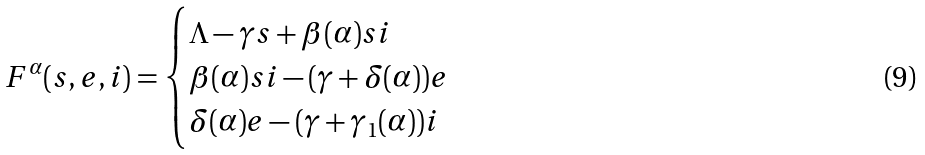Convert formula to latex. <formula><loc_0><loc_0><loc_500><loc_500>F ^ { \alpha } ( s , e , i ) = \begin{cases} \Lambda - \gamma s + \beta ( \alpha ) s i \\ \beta ( \alpha ) s i - ( \gamma + \delta ( \alpha ) ) e \\ \delta ( \alpha ) e - ( \gamma + \gamma _ { 1 } ( \alpha ) ) i \end{cases}</formula> 